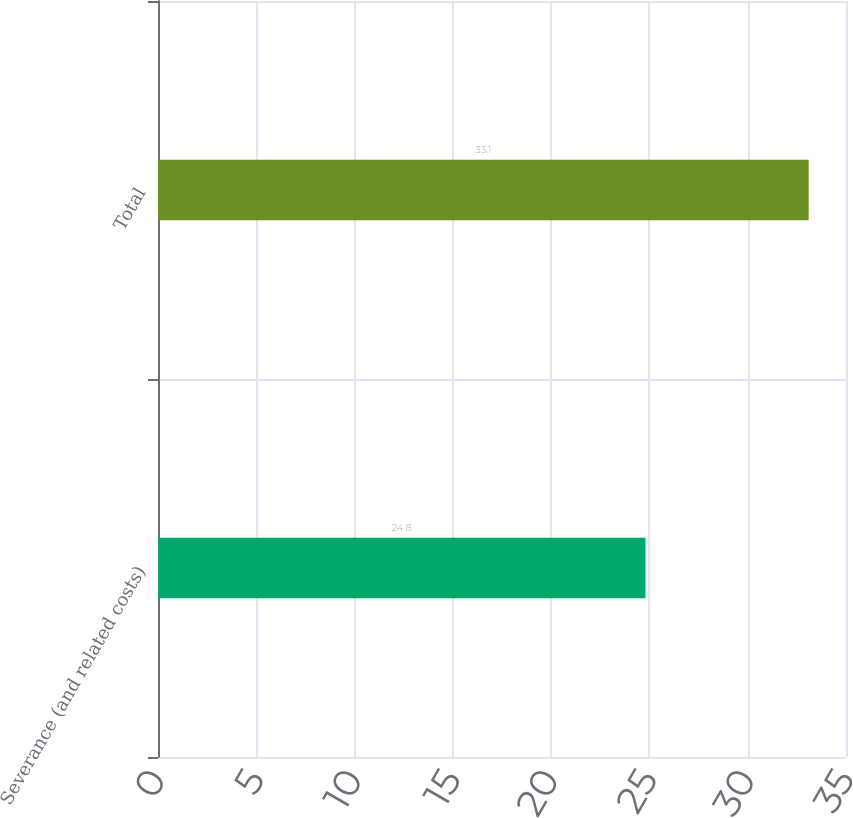Convert chart to OTSL. <chart><loc_0><loc_0><loc_500><loc_500><bar_chart><fcel>Severance (and related costs)<fcel>Total<nl><fcel>24.8<fcel>33.1<nl></chart> 